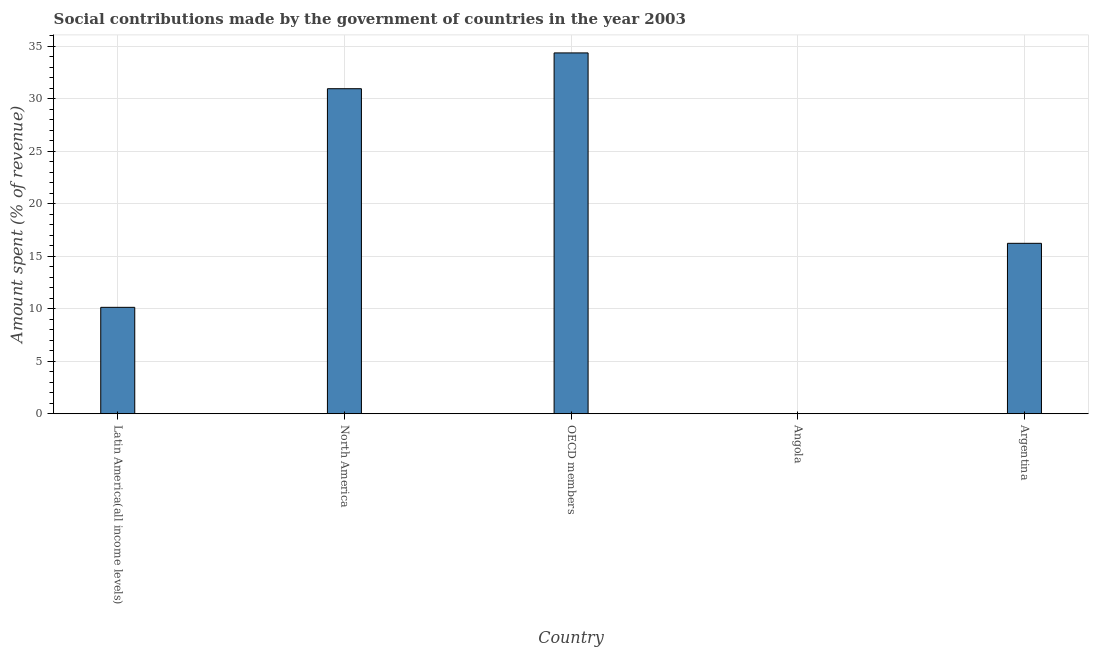Does the graph contain any zero values?
Give a very brief answer. No. Does the graph contain grids?
Offer a very short reply. Yes. What is the title of the graph?
Your response must be concise. Social contributions made by the government of countries in the year 2003. What is the label or title of the X-axis?
Provide a succinct answer. Country. What is the label or title of the Y-axis?
Provide a succinct answer. Amount spent (% of revenue). What is the amount spent in making social contributions in Argentina?
Offer a terse response. 16.23. Across all countries, what is the maximum amount spent in making social contributions?
Offer a very short reply. 34.36. Across all countries, what is the minimum amount spent in making social contributions?
Ensure brevity in your answer.  0.01. In which country was the amount spent in making social contributions maximum?
Make the answer very short. OECD members. In which country was the amount spent in making social contributions minimum?
Your answer should be very brief. Angola. What is the sum of the amount spent in making social contributions?
Offer a terse response. 91.68. What is the difference between the amount spent in making social contributions in Argentina and Latin America(all income levels)?
Ensure brevity in your answer.  6.1. What is the average amount spent in making social contributions per country?
Offer a terse response. 18.34. What is the median amount spent in making social contributions?
Your answer should be very brief. 16.23. What is the ratio of the amount spent in making social contributions in Argentina to that in OECD members?
Offer a terse response. 0.47. What is the difference between the highest and the second highest amount spent in making social contributions?
Your answer should be very brief. 3.41. What is the difference between the highest and the lowest amount spent in making social contributions?
Ensure brevity in your answer.  34.35. In how many countries, is the amount spent in making social contributions greater than the average amount spent in making social contributions taken over all countries?
Offer a terse response. 2. How many bars are there?
Give a very brief answer. 5. How many countries are there in the graph?
Give a very brief answer. 5. What is the Amount spent (% of revenue) in Latin America(all income levels)?
Give a very brief answer. 10.13. What is the Amount spent (% of revenue) in North America?
Provide a succinct answer. 30.95. What is the Amount spent (% of revenue) in OECD members?
Your answer should be compact. 34.36. What is the Amount spent (% of revenue) of Angola?
Make the answer very short. 0.01. What is the Amount spent (% of revenue) in Argentina?
Provide a succinct answer. 16.23. What is the difference between the Amount spent (% of revenue) in Latin America(all income levels) and North America?
Provide a short and direct response. -20.82. What is the difference between the Amount spent (% of revenue) in Latin America(all income levels) and OECD members?
Offer a very short reply. -24.23. What is the difference between the Amount spent (% of revenue) in Latin America(all income levels) and Angola?
Your answer should be compact. 10.12. What is the difference between the Amount spent (% of revenue) in Latin America(all income levels) and Argentina?
Offer a very short reply. -6.1. What is the difference between the Amount spent (% of revenue) in North America and OECD members?
Provide a short and direct response. -3.41. What is the difference between the Amount spent (% of revenue) in North America and Angola?
Provide a short and direct response. 30.94. What is the difference between the Amount spent (% of revenue) in North America and Argentina?
Offer a terse response. 14.72. What is the difference between the Amount spent (% of revenue) in OECD members and Angola?
Provide a succinct answer. 34.35. What is the difference between the Amount spent (% of revenue) in OECD members and Argentina?
Your answer should be compact. 18.13. What is the difference between the Amount spent (% of revenue) in Angola and Argentina?
Make the answer very short. -16.22. What is the ratio of the Amount spent (% of revenue) in Latin America(all income levels) to that in North America?
Offer a very short reply. 0.33. What is the ratio of the Amount spent (% of revenue) in Latin America(all income levels) to that in OECD members?
Give a very brief answer. 0.29. What is the ratio of the Amount spent (% of revenue) in Latin America(all income levels) to that in Angola?
Your answer should be compact. 898.95. What is the ratio of the Amount spent (% of revenue) in Latin America(all income levels) to that in Argentina?
Offer a very short reply. 0.62. What is the ratio of the Amount spent (% of revenue) in North America to that in OECD members?
Offer a terse response. 0.9. What is the ratio of the Amount spent (% of revenue) in North America to that in Angola?
Give a very brief answer. 2746.03. What is the ratio of the Amount spent (% of revenue) in North America to that in Argentina?
Your response must be concise. 1.91. What is the ratio of the Amount spent (% of revenue) in OECD members to that in Angola?
Offer a terse response. 3048.51. What is the ratio of the Amount spent (% of revenue) in OECD members to that in Argentina?
Give a very brief answer. 2.12. 